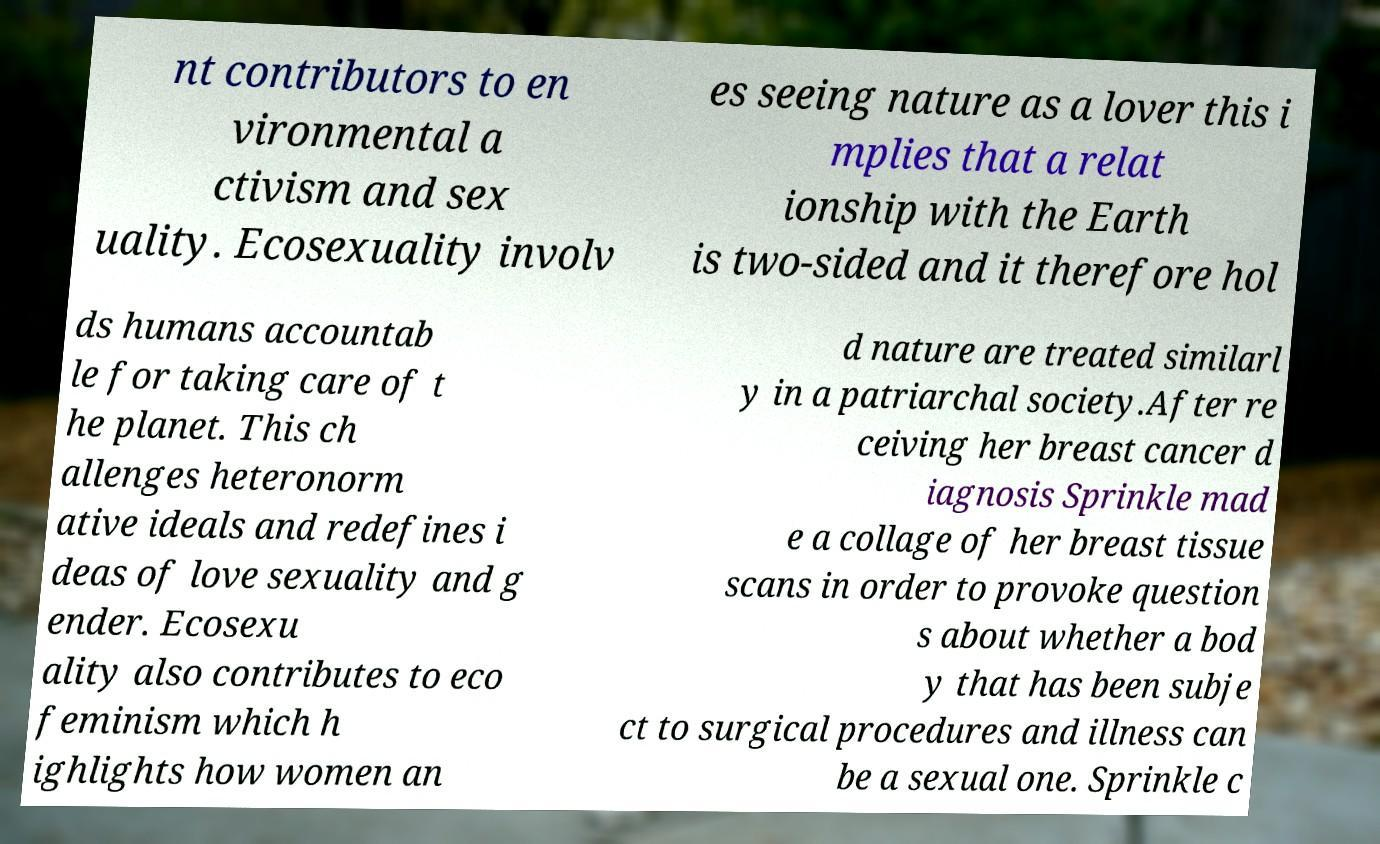I need the written content from this picture converted into text. Can you do that? nt contributors to en vironmental a ctivism and sex uality. Ecosexuality involv es seeing nature as a lover this i mplies that a relat ionship with the Earth is two-sided and it therefore hol ds humans accountab le for taking care of t he planet. This ch allenges heteronorm ative ideals and redefines i deas of love sexuality and g ender. Ecosexu ality also contributes to eco feminism which h ighlights how women an d nature are treated similarl y in a patriarchal society.After re ceiving her breast cancer d iagnosis Sprinkle mad e a collage of her breast tissue scans in order to provoke question s about whether a bod y that has been subje ct to surgical procedures and illness can be a sexual one. Sprinkle c 